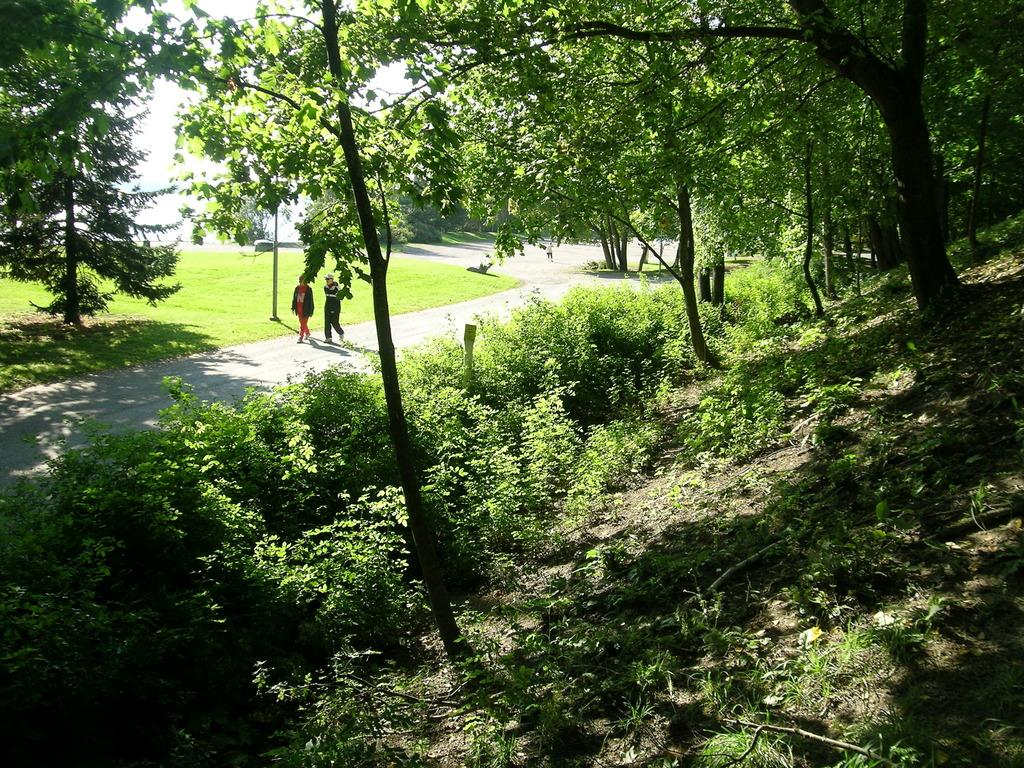What type of vegetation is on the left side of the image? There are trees on the left side of the image. What type of vegetation is on the right side of the image? There are trees on the right side of the image. What are the two people in the image doing? The two people are walking in the middle of the image. On what surface are the two people walking? The two people are walking on a road. What type of queen is present in the image? There is no queen present in the image; it features trees, two people walking, and a road. What type of farmer can be seen working in the image? There is no farmer present in the image. 